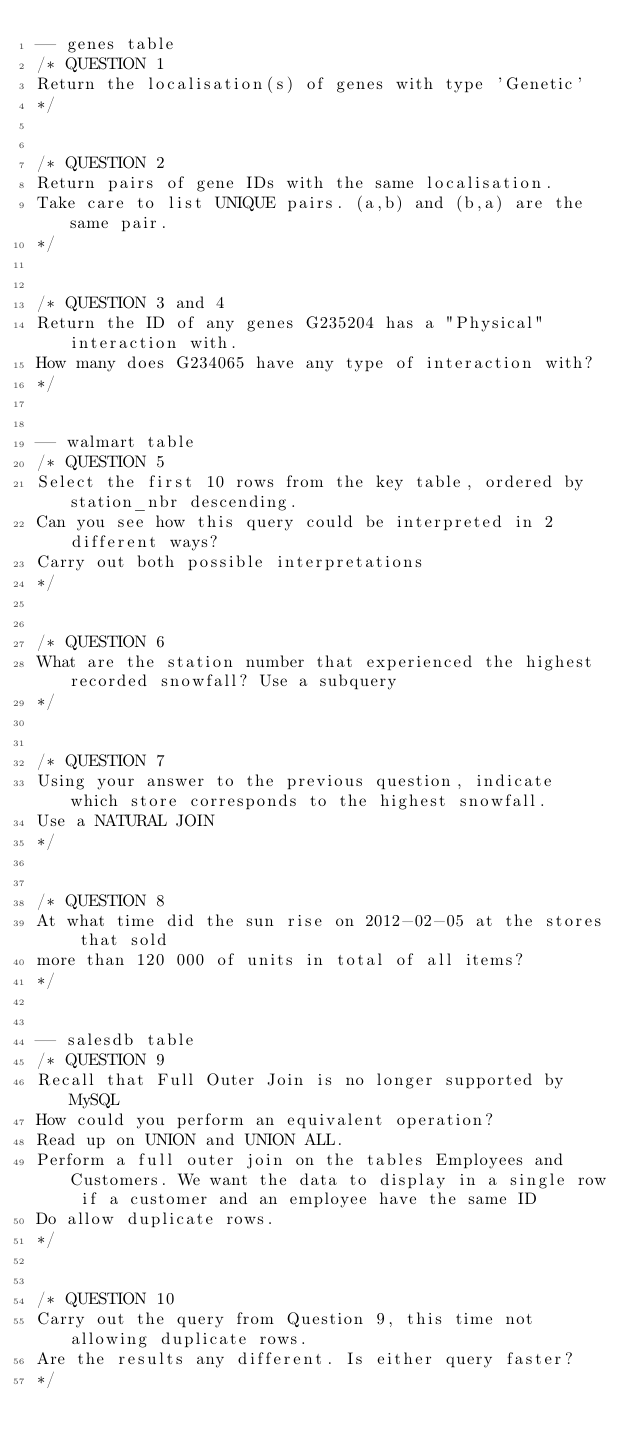Convert code to text. <code><loc_0><loc_0><loc_500><loc_500><_SQL_>-- genes table
/* QUESTION 1
Return the localisation(s) of genes with type 'Genetic'
*/


/* QUESTION 2
Return pairs of gene IDs with the same localisation. 
Take care to list UNIQUE pairs. (a,b) and (b,a) are the same pair.
*/


/* QUESTION 3 and 4
Return the ID of any genes G235204 has a "Physical" interaction with.
How many does G234065 have any type of interaction with?
*/


-- walmart table
/* QUESTION 5
Select the first 10 rows from the key table, ordered by station_nbr descending.
Can you see how this query could be interpreted in 2 different ways? 
Carry out both possible interpretations
*/


/* QUESTION 6
What are the station number that experienced the highest recorded snowfall? Use a subquery
*/


/* QUESTION 7
Using your answer to the previous question, indicate which store corresponds to the highest snowfall. 
Use a NATURAL JOIN
*/


/* QUESTION 8
At what time did the sun rise on 2012-02-05 at the stores that sold 
more than 120 000 of units in total of all items?
*/


-- salesdb table
/* QUESTION 9
Recall that Full Outer Join is no longer supported by MySQL
How could you perform an equivalent operation? 
Read up on UNION and UNION ALL.
Perform a full outer join on the tables Employees and Customers. We want the data to display in a single row if a customer and an employee have the same ID
Do allow duplicate rows.
*/


/* QUESTION 10
Carry out the query from Question 9, this time not allowing duplicate rows.
Are the results any different. Is either query faster?
*/

</code> 